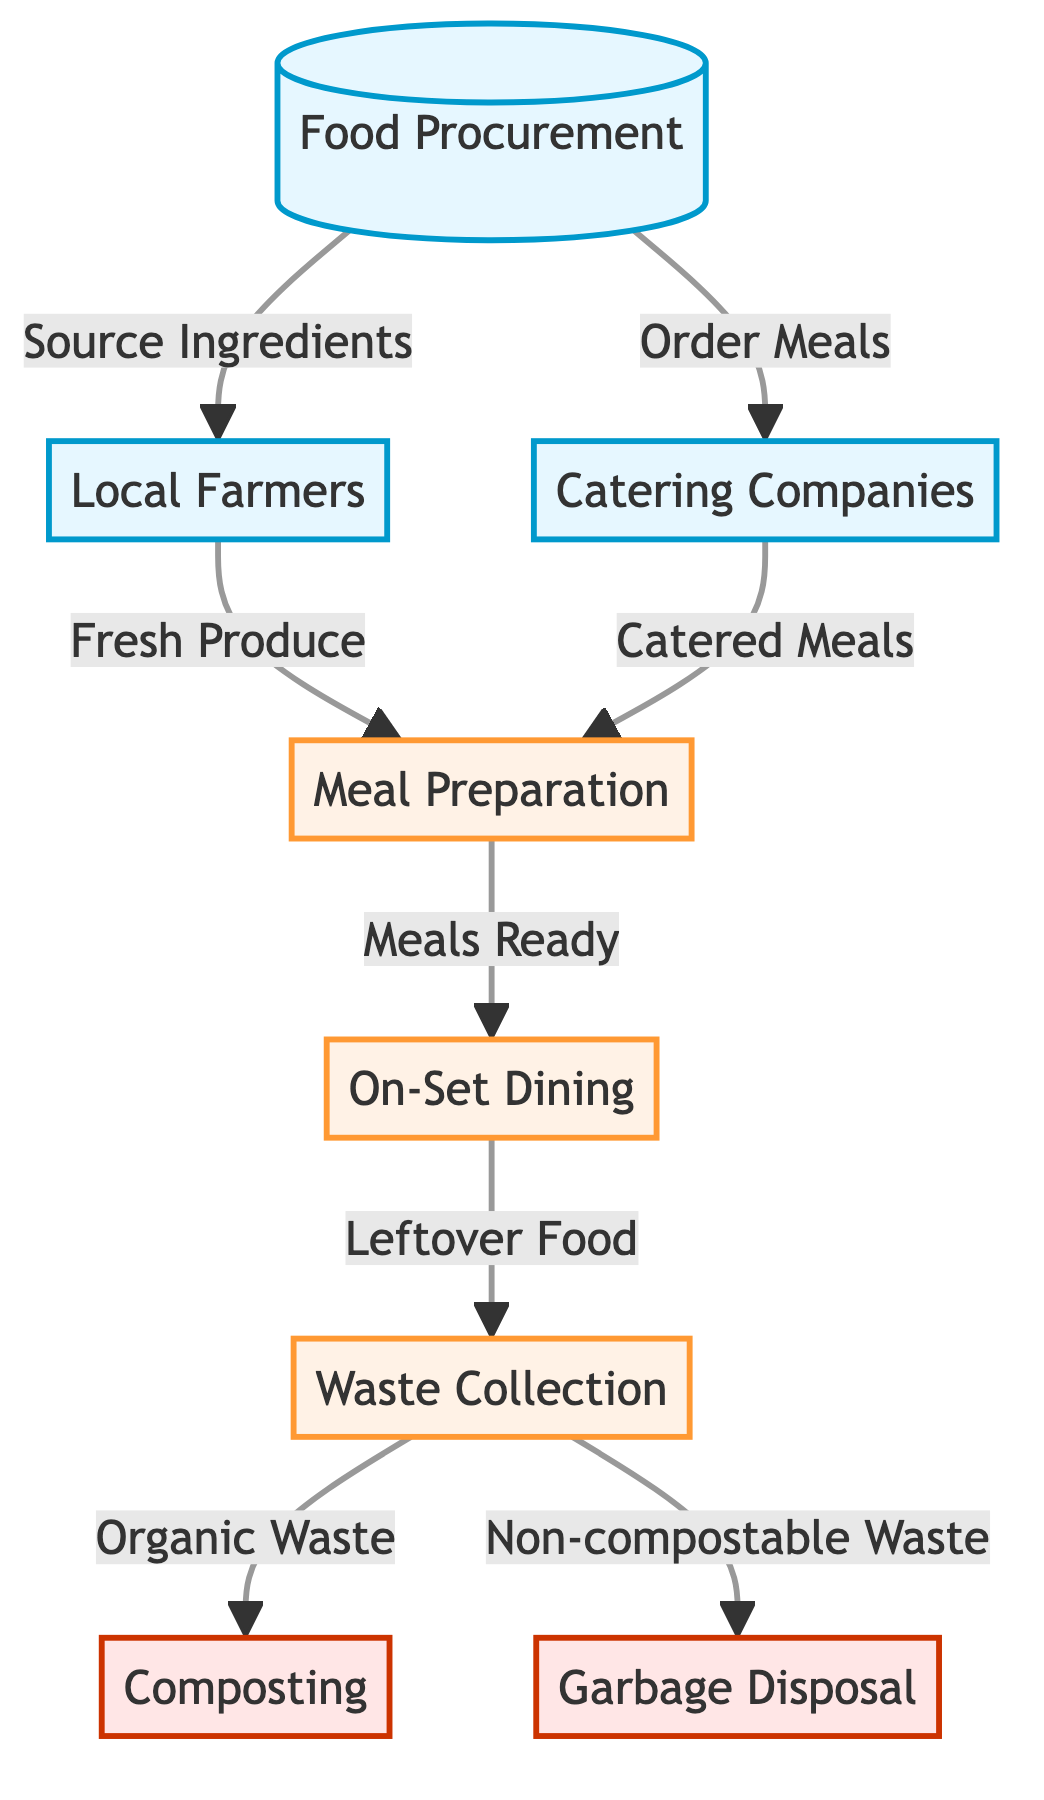What is the first step in the production designer's meal lifecycle? The first step is "Food Procurement," which is represented as the beginning node in the diagram. It indicates the initial action taken before meals can be prepared or sourced.
Answer: Food Procurement How many sources of food procurement are listed in the diagram? The diagram lists three sources: "Local Farmers," "Catering Companies," and "Food Procurement." Each of these is a distinct source for obtaining food.
Answer: 3 What types of meals do local farmers provide? Local farmers provide "Fresh Produce," which is indicated in the diagram as the link from "Local Farmers" to "Meal Preparation." This implies their contribution is primarily in providing fresh ingredients.
Answer: Fresh Produce Which node directly follows "Meal Preparation" in the flow? The node that follows "Meal Preparation" is "On-Set Dining." This transition shows that after meals are prepared, they are then available for dining on set.
Answer: On-Set Dining What happens to leftover food according to the diagram? Leftover food goes to "Waste Collection," indicating that any food not consumed is collected for further processing, which is outlined in the flow diagram.
Answer: Waste Collection Which type of waste is linked to composting in this diagram? "Organic Waste" is the type of waste linked to composting, as shown by the direct connection from "Waste Collection" to "Composting" in the flow. This indicates a process for recycling natural waste.
Answer: Organic Waste How many disposal methods are identified in the lifecycle of on-set meals? There are two disposal methods identified: "Composting" and "Garbage Disposal," which are shown in the diagram as outcomes of the "Waste Collection" process.
Answer: 2 What does a catering company provide in this food chain? A catering company provides "Catered Meals," which is noted in the flow as the connection from "Catering Companies" to "Meal Preparation," indicating their role in supplying ready-made meals for the set.
Answer: Catered Meals What is the last step in the lifecycle of the production designer's meals? The last step is "Garbage Disposal," which represents the endpoint for non-compostable waste collected from on-set dining, depicting the final disposal process.
Answer: Garbage Disposal 